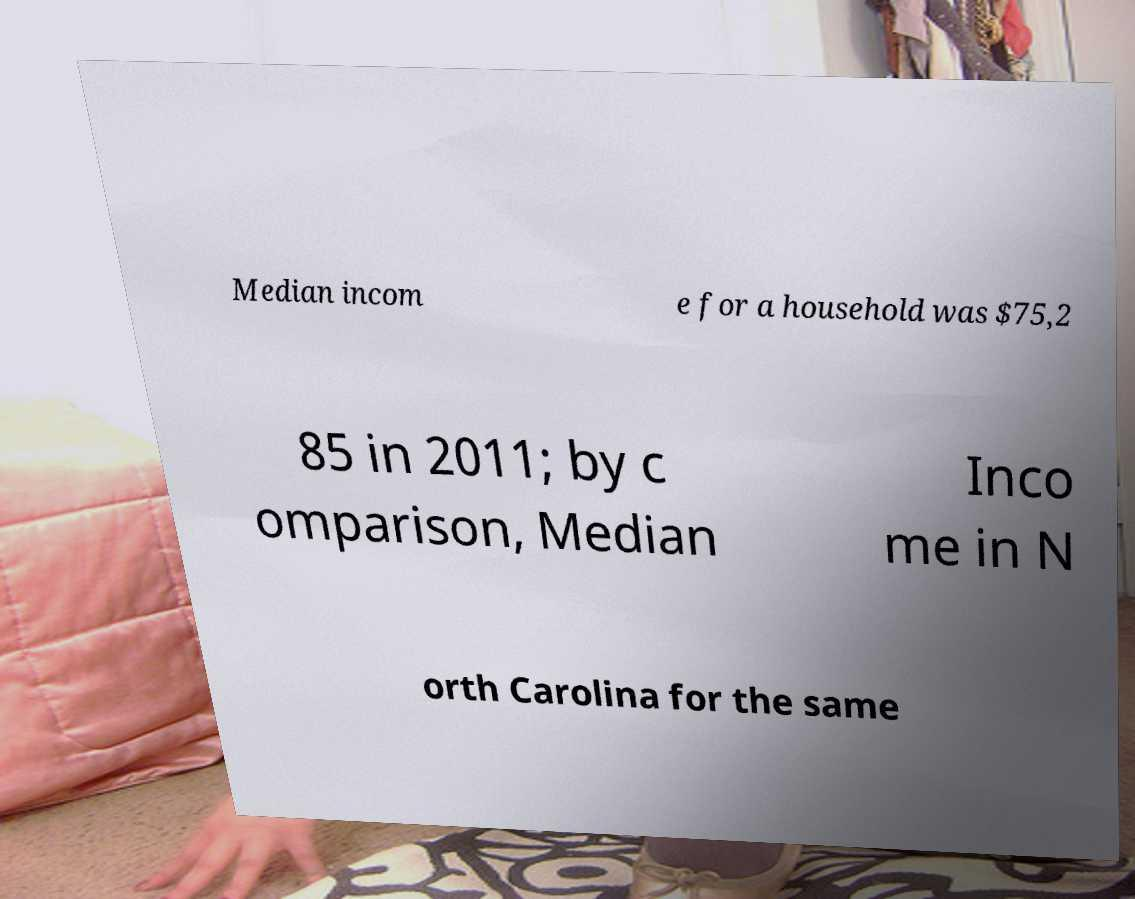Can you read and provide the text displayed in the image?This photo seems to have some interesting text. Can you extract and type it out for me? Median incom e for a household was $75,2 85 in 2011; by c omparison, Median Inco me in N orth Carolina for the same 